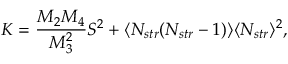<formula> <loc_0><loc_0><loc_500><loc_500>K = \frac { M _ { 2 } M _ { 4 } } { M _ { 3 } ^ { 2 } } S ^ { 2 } + \langle N _ { s t r } ( N _ { s t r } - 1 ) \rangle \langle N _ { s t r } \rangle ^ { 2 } ,</formula> 